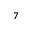Convert formula to latex. <formula><loc_0><loc_0><loc_500><loc_500>_ { 7 }</formula> 